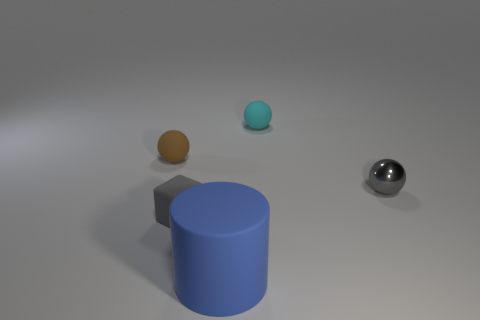Subtract all small cyan balls. How many balls are left? 2 Add 5 rubber blocks. How many objects exist? 10 Subtract all cyan balls. How many balls are left? 2 Subtract all cylinders. How many objects are left? 4 Subtract all yellow balls. Subtract all green blocks. How many balls are left? 3 Subtract all cyan rubber balls. Subtract all large blue matte objects. How many objects are left? 3 Add 4 tiny brown rubber things. How many tiny brown rubber things are left? 5 Add 5 brown spheres. How many brown spheres exist? 6 Subtract 1 gray cubes. How many objects are left? 4 Subtract 2 balls. How many balls are left? 1 